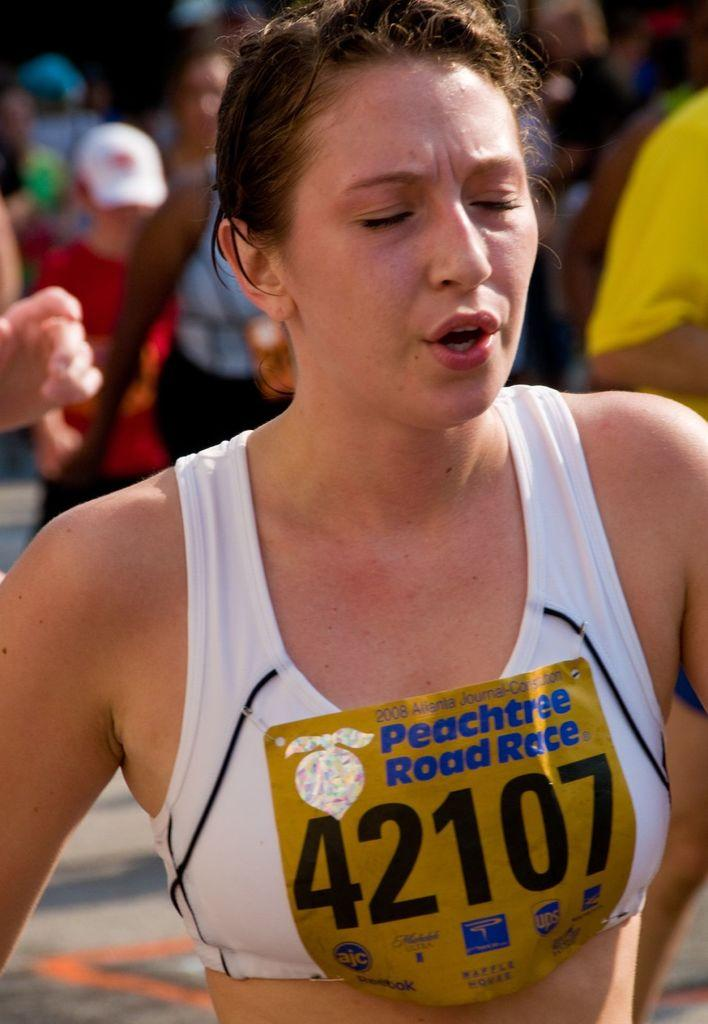Provide a one-sentence caption for the provided image. A girl is running with her eyes closed and she has a sign on that says 42107. 